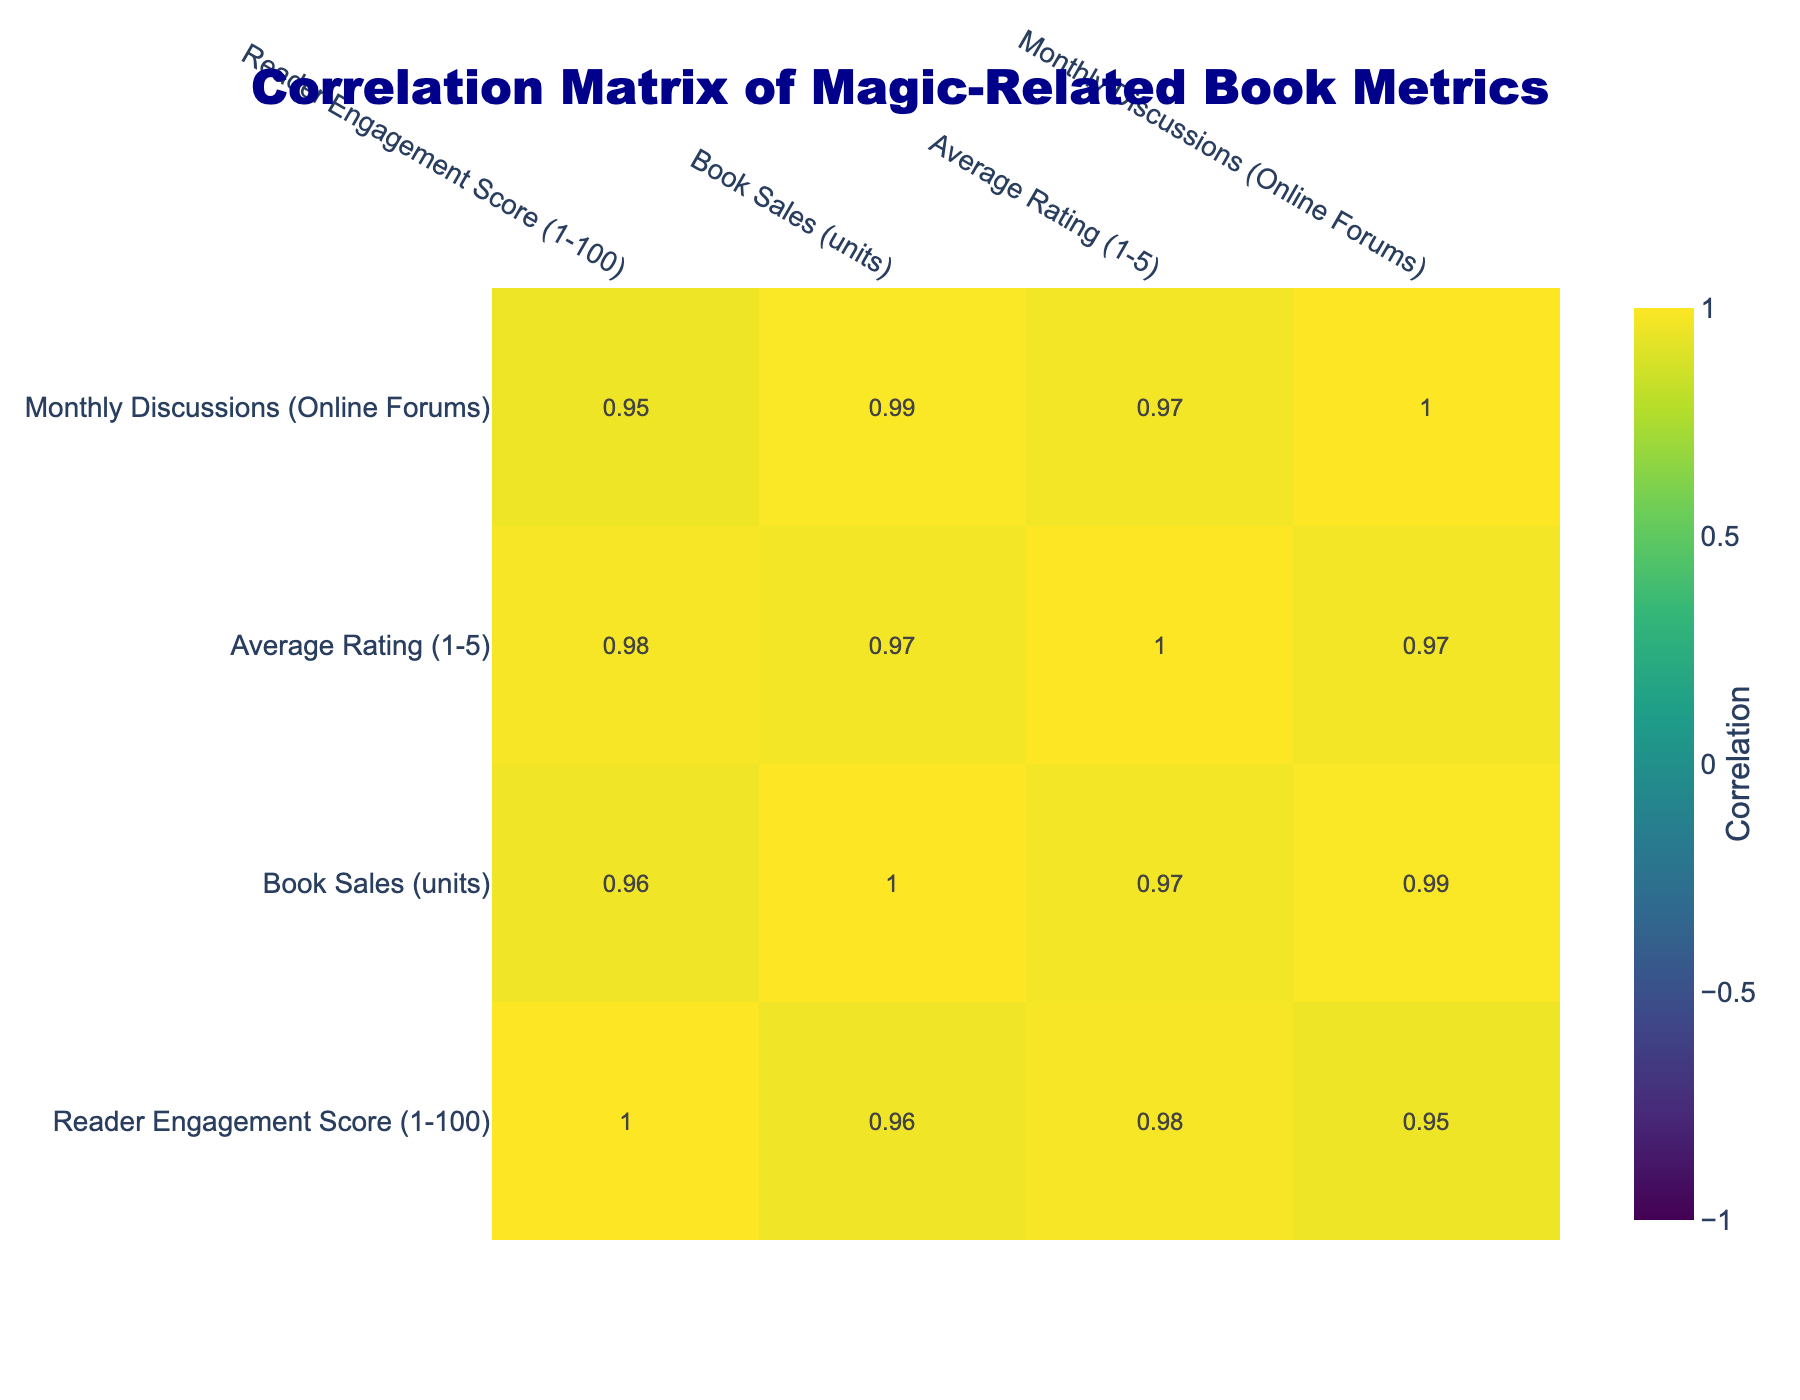What is the Reader Engagement Score of "Magic and the Mind: Cognitive Processes at Play"? The table lists "Magic and the Mind: Cognitive Processes at Play" with a Reader Engagement Score of 85.
Answer: 85 What are the Book Sales of "Magical Thinking: An Exploration of the Unseen"? According to the data in the table, "Magical Thinking: An Exploration of the Unseen" has Book Sales of 1500 units.
Answer: 1500 Is the Average Rating of "The Art of Deception: Psychology of Magic Tricks" higher than 4.5? The Average Rating for "The Art of Deception: Psychology of Magic Tricks" is 4.6, which is indeed higher than 4.5.
Answer: Yes How many titles have a Reader Engagement Score greater than 75? The titles with a Reader Engagement Score greater than 75 are: "The Magic Within: Psychological Techniques of Magicians" (82), "Magic and the Mind: Cognitive Processes at Play" (85), and "The Art of Deception: Psychology of Magic Tricks" (79). This counts to a total of 3 titles.
Answer: 3 What is the difference in Book Sales between the title with the highest Reader Engagement Score and the title with the lowest? The title with the highest Reader Engagement Score is "Magic and the Mind: Cognitive Processes at Play" with 20000 Book Sales, and the title with the lowest score is "Magical Thinking: An Exploration of the Unseen" with 1500 Book Sales. The difference is calculated as 20000 - 1500 = 18500.
Answer: 18500 What is the average Book Sales of titles with Reader Engagement Scores less than 70? The titles with Reader Engagement Scores less than 70 are "Mind Games: The Science Behind Illusion" (9500), "Illusion and Perception: A Study of Magical Thinking" (3000), "Magical Thinking: An Exploration of the Unseen" (1500), and "Beyond the Trick: The Psychology of Magical Performance" (7500). The average is calculated as (9500 + 3000 + 1500 + 7500) / 4 = 2875.
Answer: 2875 Does the title "The Magic Within: Psychological Techniques of Magicians" have a higher Average Rating than the title with the most Monthly Discussions? "The Magic Within: Psychological Techniques of Magicians" has an Average Rating of 4.7. The title with the highest Monthly Discussions, "Magic and the Mind: Cognitive Processes at Play," has an Average Rating of 4.8. Thus, "The Magic Within" does not have a higher rating.
Answer: No What is the total number of Monthly Discussions for all titles listed? The Monthly Discussions listed in the table are: 350, 250, 400, 150, 200, 500, 300, 100, 450, and 220. Adding these gives: 350 + 250 + 400 + 150 + 200 + 500 + 300 + 100 + 450 + 220 = 3020.
Answer: 3020 